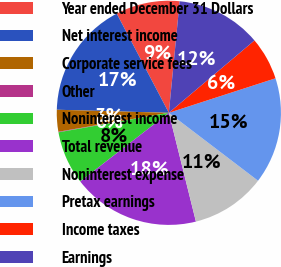Convert chart to OTSL. <chart><loc_0><loc_0><loc_500><loc_500><pie_chart><fcel>Year ended December 31 Dollars<fcel>Net interest income<fcel>Corporate service fees<fcel>Other<fcel>Noninterest income<fcel>Total revenue<fcel>Noninterest expense<fcel>Pretax earnings<fcel>Income taxes<fcel>Earnings<nl><fcel>9.24%<fcel>16.86%<fcel>3.14%<fcel>0.08%<fcel>7.71%<fcel>18.39%<fcel>10.76%<fcel>15.34%<fcel>6.19%<fcel>12.29%<nl></chart> 